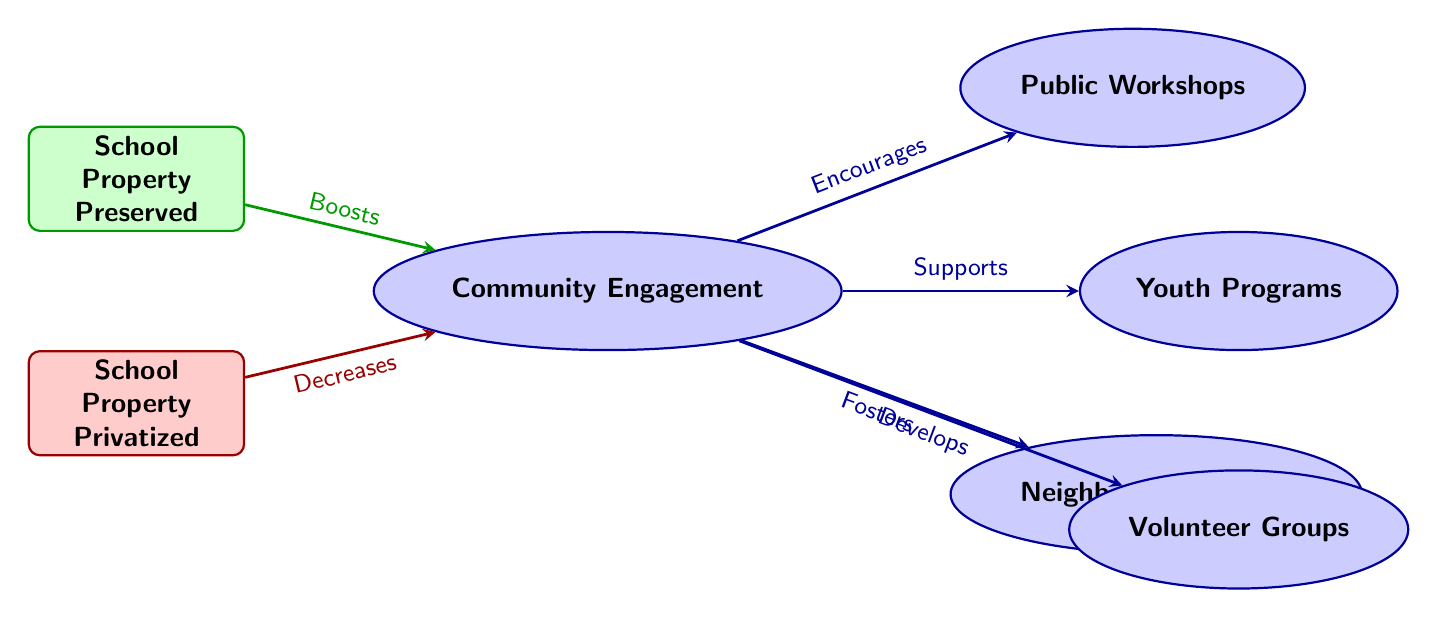What type of school property is connected to increased community engagement? The diagram indicates that "School Property Preserved" has a direct connection to "Community Engagement," implying a positive correlation between preserved school properties and community involvement.
Answer: School Property Preserved How many engagement nodes are present in the diagram? By counting the ellipse-shaped nodes labeled with engagement terms, we find four engagement nodes: Public Workshops, Youth Programs, Neighborhood Events, and Volunteer Groups.
Answer: 4 What effect does privatized school property have on community engagement? The arrow from "School Property Privatized" to "Community Engagement" shows a decrease, indicating that privatized properties negatively affect community involvement.
Answer: Decreases Which engagement type directly supports youth programs? The diagram shows that "Community Engagement" has a direct supporting connection to "Youth Programs," indicating that community involvement is essential for these programs to flourish.
Answer: Supports What type of connection exists between community engagement and neighborhood events? The diagram illustrates a "fosters" relation from "Community Engagement" to "Neighborhood Events," meaning that increased community engagement helps develop these events.
Answer: Fosters What is the relationship between preserved school property and public workshops? The diagram indicates that "School Property Preserved" boosts "Community Engagement," which in turn encourages public workshops, establishing an indirect relationship where preservation benefits workshops.
Answer: Encourages How does community engagement influence volunteer groups? The diagram indicates a "develops" connection from "Community Engagement" to "Volunteer Groups," which means that higher community involvement leads to the development of these groups.
Answer: Develops 